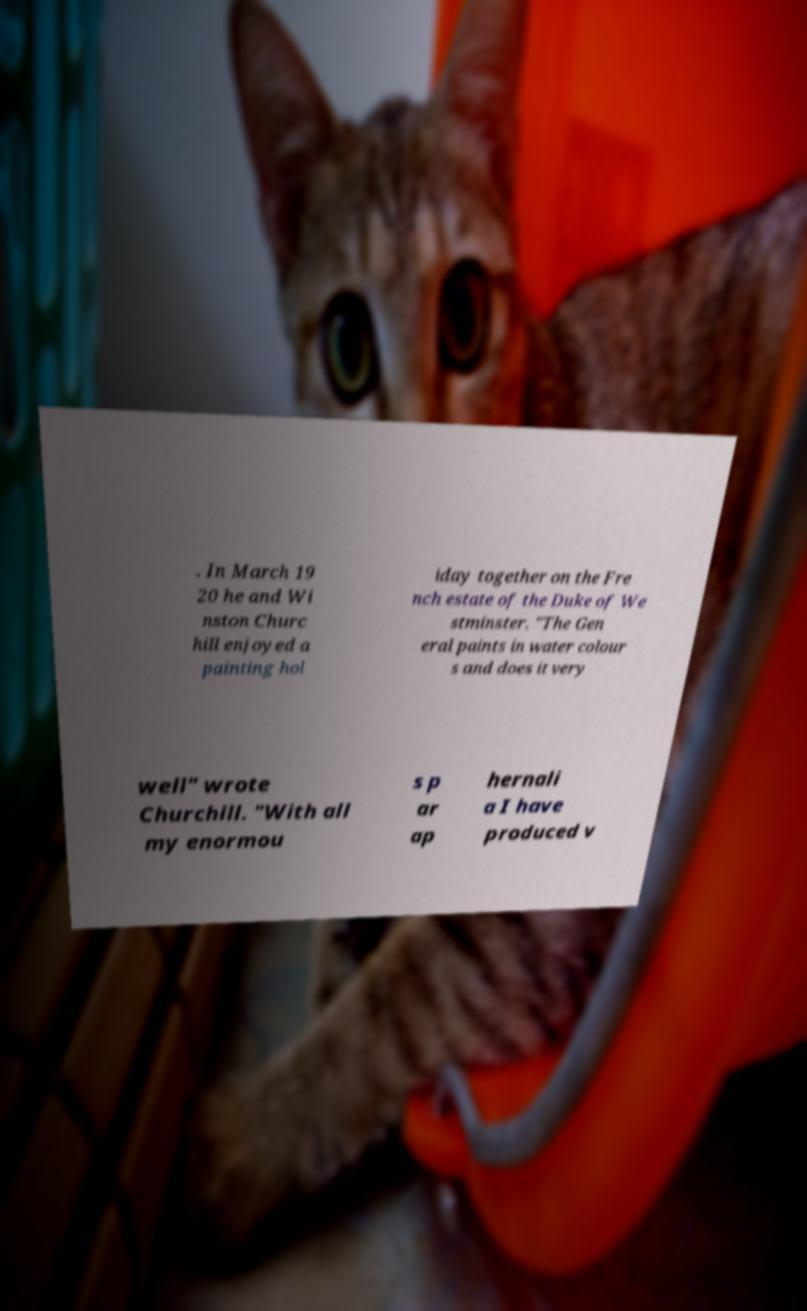What messages or text are displayed in this image? I need them in a readable, typed format. . In March 19 20 he and Wi nston Churc hill enjoyed a painting hol iday together on the Fre nch estate of the Duke of We stminster. "The Gen eral paints in water colour s and does it very well" wrote Churchill. "With all my enormou s p ar ap hernali a I have produced v 